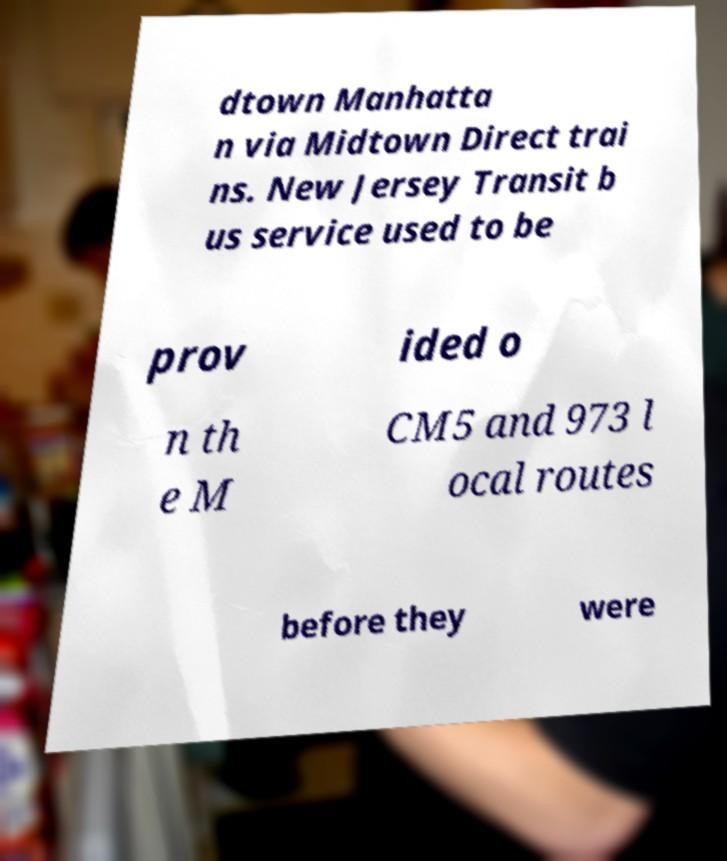Can you read and provide the text displayed in the image?This photo seems to have some interesting text. Can you extract and type it out for me? dtown Manhatta n via Midtown Direct trai ns. New Jersey Transit b us service used to be prov ided o n th e M CM5 and 973 l ocal routes before they were 